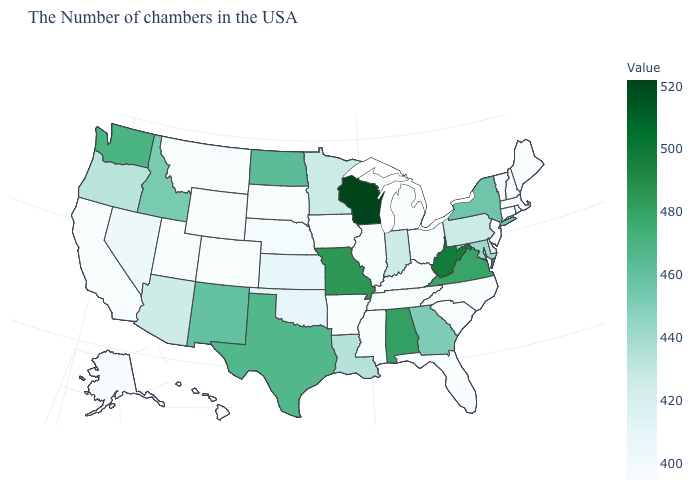Is the legend a continuous bar?
Be succinct. Yes. Does Maine have the highest value in the Northeast?
Be succinct. No. Among the states that border Oklahoma , which have the highest value?
Concise answer only. Missouri. Does Wisconsin have the highest value in the USA?
Concise answer only. Yes. Does Wisconsin have the highest value in the USA?
Write a very short answer. Yes. Among the states that border Alabama , does Georgia have the highest value?
Quick response, please. Yes. 